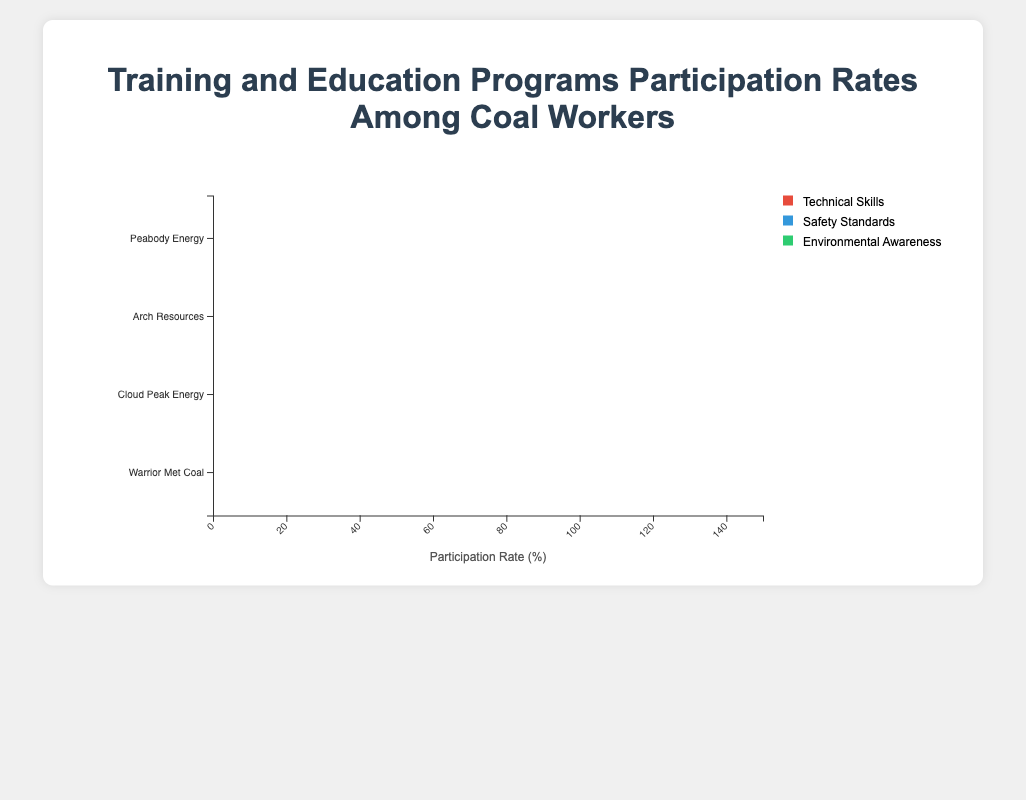What is the participation rate for safety standards programs at Warrior Met Coal? The participation rate can be seen directly on the stacked bar corresponding to Warrior Met Coal. For the green section (Safety Standards), the rate is 70%.
Answer: 70% Which company has the highest total participation rate across all education programs? To determine the total participation rate for each company, sum the three segments (Technical Skills, Safety Standards, Environmental Awareness) for each company. For Peabody Energy: 45 + 60 + 30 = 135, Arch Resources: 50 + 55 + 35 = 140, Cloud Peak Energy: 40 + 65 + 20 = 125, Warrior Met Coal: 35 + 70 + 25 = 130. Arch Resources has the highest total participation rate.
Answer: Arch Resources Which program type has the highest average participation rate? Calculate the average participation rate for each program by summing the rates across companies and dividing by the number of companies (4). Technical Skills: (45 + 50 + 40 + 35) / 4 = 42.5, Safety Standards: (60 + 55 + 65 + 70) / 4 = 62.5, Environmental Awareness: (30 + 35 + 20 + 25) / 4 = 27.5. Safety Standards has the highest average participation rate.
Answer: Safety Standards Compare the participation rates in environmental awareness programs between Peabody Energy and Cloud Peak Energy. Which is higher and by how much? Compare the participation rates directly. Peabody Energy's rate is 30%, and Cloud Peak Energy's rate is 20%. The difference is 30% - 20% = 10%. Peabody Energy's rate is 10% higher.
Answer: Peabody Energy by 10% What is the total participation rate for technical skills programs across all companies? Sum the participation rates for Technical Skills from all companies. (45 + 50 + 40 + 35) = 170.
Answer: 170 Which company has the least participation rate in environmental awareness programs? Compare the visual length of the bars for Environmental Awareness (blue sections). Warrior Met Coal's rate is 25%, Peabody Energy's is 30%, Cloud Peak Energy's is 20%, and Arch Resources's is 35%. Cloud Peak Energy has the least participation rate.
Answer: Cloud Peak Energy Is the participation rate in safety standards programs for Arch Resources greater than that in technical skills programs for Warrior Met Coal? Compare the participation rates: Arch Resources has 55% in Safety Standards, whereas Warrior Met Coal has 35% in Technical Skills. 55% > 35%, so the participation rate for Arch Resources in Safety Standards is greater.
Answer: Yes What is the difference between the highest and lowest participation rates in technical skills programs? The participation rates for Technical Skills are: Peabody Energy 45%, Arch Resources 50%, Cloud Peak Energy 40%, Warrior Met Coal 35%. The highest rate is 50% (Arch Resources) and the lowest is 35% (Warrior Met Coal). The difference is 50% - 35% = 15%.
Answer: 15% Which program type has the largest range in participation rates across the companies? Calculate the range for each program type by subtracting the smallest from the largest participation rate. Technical Skills: 50 - 35 = 15, Safety Standards: 70 - 55 = 15, Environmental Awareness: 35 - 20 = 15. Each program type has a range of 15%.
Answer: All What is the combined participation rate for Cloud Peak Energy in all programs? Sum the participation rates of Technical Skills, Safety Standards, and Environmental Awareness for Cloud Peak Energy. (40 + 65 + 20) = 125.
Answer: 125 